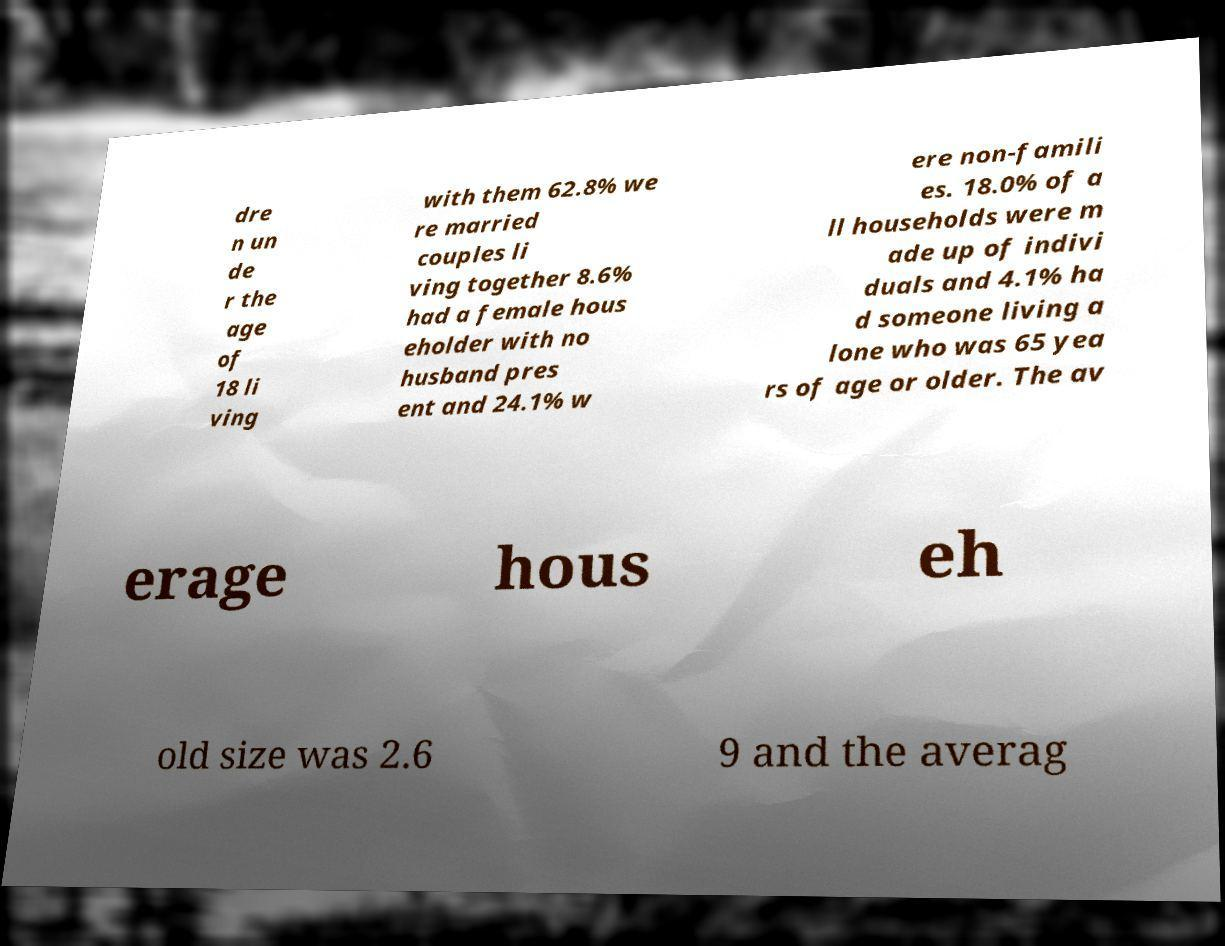Can you accurately transcribe the text from the provided image for me? dre n un de r the age of 18 li ving with them 62.8% we re married couples li ving together 8.6% had a female hous eholder with no husband pres ent and 24.1% w ere non-famili es. 18.0% of a ll households were m ade up of indivi duals and 4.1% ha d someone living a lone who was 65 yea rs of age or older. The av erage hous eh old size was 2.6 9 and the averag 